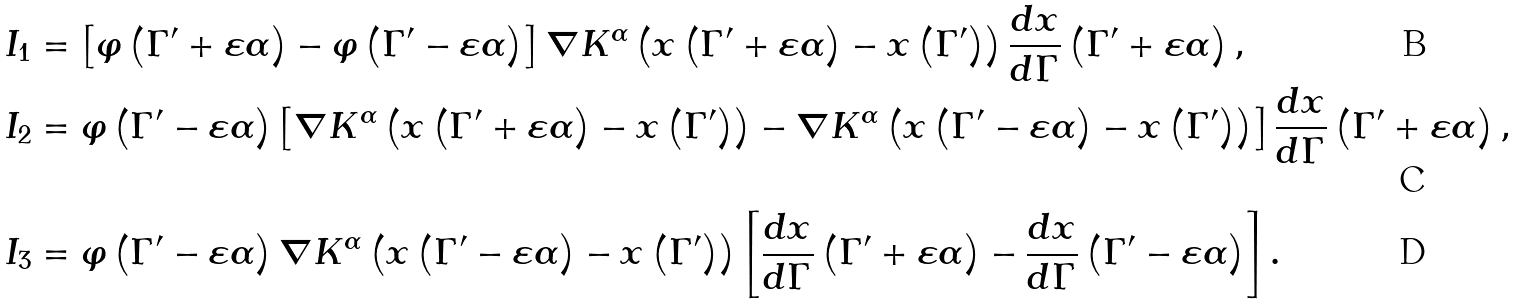Convert formula to latex. <formula><loc_0><loc_0><loc_500><loc_500>I _ { 1 } & = \left [ \varphi \left ( \Gamma ^ { \prime } + \varepsilon \alpha \right ) - \varphi \left ( \Gamma ^ { \prime } - \varepsilon \alpha \right ) \right ] \nabla K ^ { \alpha } \left ( x \left ( \Gamma ^ { \prime } + \varepsilon \alpha \right ) - x \left ( \Gamma ^ { \prime } \right ) \right ) \frac { d x } { d \Gamma } \left ( \Gamma ^ { \prime } + \varepsilon \alpha \right ) , \\ I _ { 2 } & = \varphi \left ( \Gamma ^ { \prime } - \varepsilon \alpha \right ) \left [ \nabla K ^ { \alpha } \left ( x \left ( \Gamma ^ { \prime } + \varepsilon \alpha \right ) - x \left ( \Gamma ^ { \prime } \right ) \right ) - \nabla K ^ { \alpha } \left ( x \left ( \Gamma ^ { \prime } - \varepsilon \alpha \right ) - x \left ( \Gamma ^ { \prime } \right ) \right ) \right ] \frac { d x } { d \Gamma } \left ( \Gamma ^ { \prime } + \varepsilon \alpha \right ) , \\ I _ { 3 } & = \varphi \left ( \Gamma ^ { \prime } - \varepsilon \alpha \right ) \nabla K ^ { \alpha } \left ( x \left ( \Gamma ^ { \prime } - \varepsilon \alpha \right ) - x \left ( \Gamma ^ { \prime } \right ) \right ) \left [ \frac { d x } { d \Gamma } \left ( \Gamma ^ { \prime } + \varepsilon \alpha \right ) - \frac { d x } { d \Gamma } \left ( \Gamma ^ { \prime } - \varepsilon \alpha \right ) \right ] .</formula> 